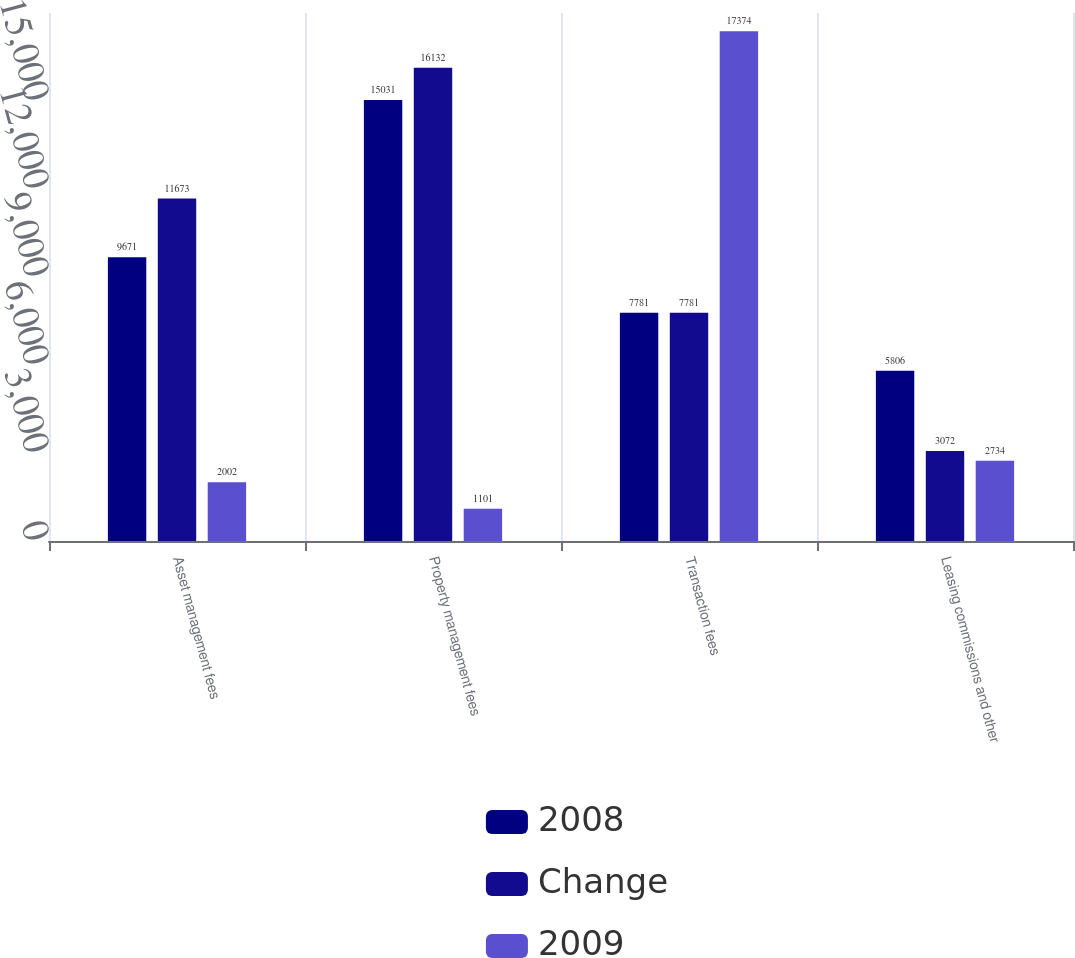Convert chart. <chart><loc_0><loc_0><loc_500><loc_500><stacked_bar_chart><ecel><fcel>Asset management fees<fcel>Property management fees<fcel>Transaction fees<fcel>Leasing commissions and other<nl><fcel>2008<fcel>9671<fcel>15031<fcel>7781<fcel>5806<nl><fcel>Change<fcel>11673<fcel>16132<fcel>7781<fcel>3072<nl><fcel>2009<fcel>2002<fcel>1101<fcel>17374<fcel>2734<nl></chart> 